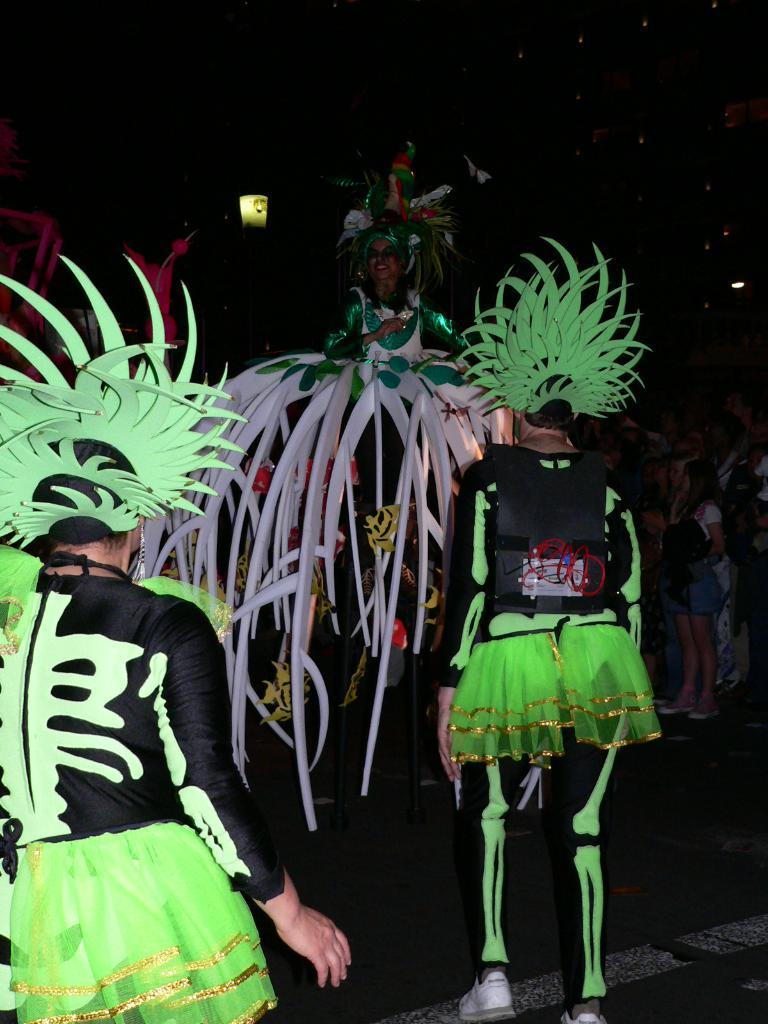Who or what can be seen in the image? There are people in the image. What colors are the people wearing? The people are wearing green and black color dresses. Can you describe the lighting in the image? The image is slightly dark. What type of van is parked behind the people in the image? There is no van present in the image. 